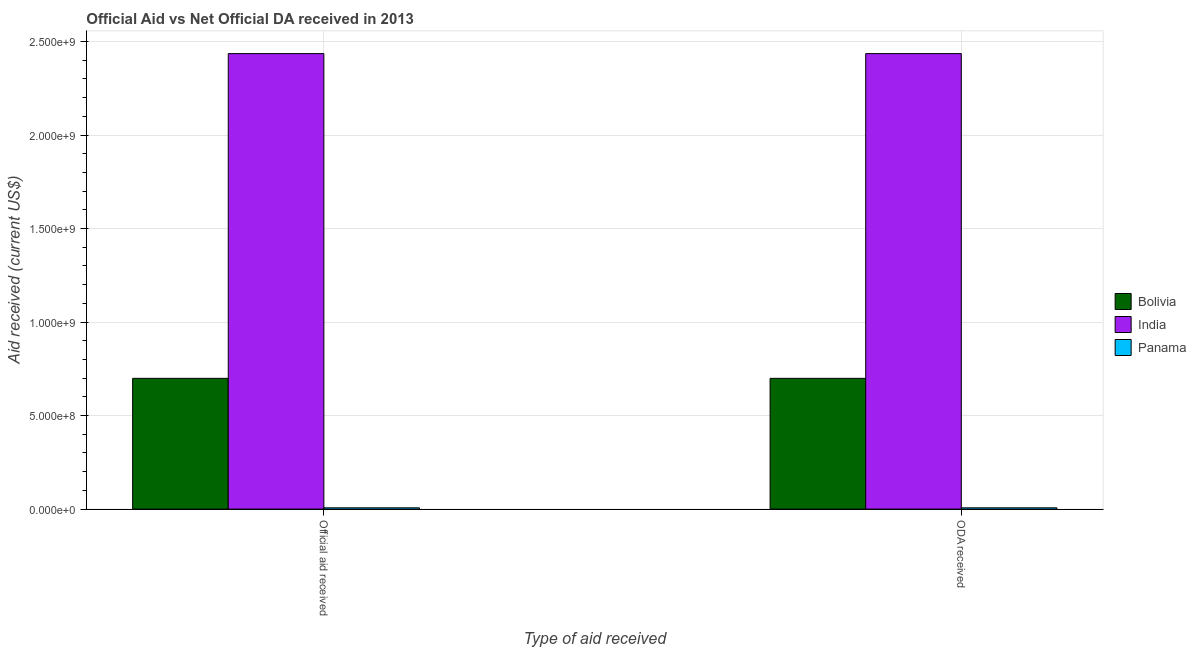How many groups of bars are there?
Give a very brief answer. 2. How many bars are there on the 2nd tick from the left?
Your response must be concise. 3. What is the label of the 1st group of bars from the left?
Your answer should be compact. Official aid received. What is the oda received in Bolivia?
Ensure brevity in your answer.  6.99e+08. Across all countries, what is the maximum official aid received?
Ensure brevity in your answer.  2.44e+09. Across all countries, what is the minimum official aid received?
Offer a very short reply. 6.87e+06. In which country was the official aid received minimum?
Ensure brevity in your answer.  Panama. What is the total oda received in the graph?
Provide a succinct answer. 3.14e+09. What is the difference between the official aid received in Bolivia and that in India?
Your answer should be very brief. -1.74e+09. What is the difference between the official aid received in Panama and the oda received in India?
Keep it short and to the point. -2.43e+09. What is the average oda received per country?
Offer a terse response. 1.05e+09. What is the difference between the official aid received and oda received in India?
Provide a succinct answer. 0. In how many countries, is the official aid received greater than 900000000 US$?
Your response must be concise. 1. What is the ratio of the official aid received in India to that in Bolivia?
Your answer should be very brief. 3.48. In how many countries, is the oda received greater than the average oda received taken over all countries?
Offer a very short reply. 1. What does the 3rd bar from the left in ODA received represents?
Offer a terse response. Panama. What does the 1st bar from the right in ODA received represents?
Keep it short and to the point. Panama. How many bars are there?
Your answer should be very brief. 6. How many countries are there in the graph?
Ensure brevity in your answer.  3. What is the difference between two consecutive major ticks on the Y-axis?
Keep it short and to the point. 5.00e+08. Are the values on the major ticks of Y-axis written in scientific E-notation?
Provide a succinct answer. Yes. Does the graph contain grids?
Offer a terse response. Yes. How many legend labels are there?
Keep it short and to the point. 3. What is the title of the graph?
Provide a succinct answer. Official Aid vs Net Official DA received in 2013 . Does "Italy" appear as one of the legend labels in the graph?
Make the answer very short. No. What is the label or title of the X-axis?
Ensure brevity in your answer.  Type of aid received. What is the label or title of the Y-axis?
Offer a very short reply. Aid received (current US$). What is the Aid received (current US$) in Bolivia in Official aid received?
Give a very brief answer. 6.99e+08. What is the Aid received (current US$) in India in Official aid received?
Your response must be concise. 2.44e+09. What is the Aid received (current US$) of Panama in Official aid received?
Keep it short and to the point. 6.87e+06. What is the Aid received (current US$) of Bolivia in ODA received?
Give a very brief answer. 6.99e+08. What is the Aid received (current US$) in India in ODA received?
Ensure brevity in your answer.  2.44e+09. What is the Aid received (current US$) in Panama in ODA received?
Ensure brevity in your answer.  6.87e+06. Across all Type of aid received, what is the maximum Aid received (current US$) in Bolivia?
Your response must be concise. 6.99e+08. Across all Type of aid received, what is the maximum Aid received (current US$) in India?
Keep it short and to the point. 2.44e+09. Across all Type of aid received, what is the maximum Aid received (current US$) in Panama?
Ensure brevity in your answer.  6.87e+06. Across all Type of aid received, what is the minimum Aid received (current US$) of Bolivia?
Give a very brief answer. 6.99e+08. Across all Type of aid received, what is the minimum Aid received (current US$) in India?
Offer a terse response. 2.44e+09. Across all Type of aid received, what is the minimum Aid received (current US$) of Panama?
Your answer should be very brief. 6.87e+06. What is the total Aid received (current US$) in Bolivia in the graph?
Provide a short and direct response. 1.40e+09. What is the total Aid received (current US$) of India in the graph?
Provide a succinct answer. 4.87e+09. What is the total Aid received (current US$) in Panama in the graph?
Your answer should be very brief. 1.37e+07. What is the difference between the Aid received (current US$) in India in Official aid received and that in ODA received?
Provide a succinct answer. 0. What is the difference between the Aid received (current US$) in Panama in Official aid received and that in ODA received?
Make the answer very short. 0. What is the difference between the Aid received (current US$) of Bolivia in Official aid received and the Aid received (current US$) of India in ODA received?
Ensure brevity in your answer.  -1.74e+09. What is the difference between the Aid received (current US$) in Bolivia in Official aid received and the Aid received (current US$) in Panama in ODA received?
Provide a short and direct response. 6.92e+08. What is the difference between the Aid received (current US$) in India in Official aid received and the Aid received (current US$) in Panama in ODA received?
Offer a very short reply. 2.43e+09. What is the average Aid received (current US$) of Bolivia per Type of aid received?
Offer a very short reply. 6.99e+08. What is the average Aid received (current US$) of India per Type of aid received?
Ensure brevity in your answer.  2.44e+09. What is the average Aid received (current US$) of Panama per Type of aid received?
Provide a succinct answer. 6.87e+06. What is the difference between the Aid received (current US$) of Bolivia and Aid received (current US$) of India in Official aid received?
Your response must be concise. -1.74e+09. What is the difference between the Aid received (current US$) of Bolivia and Aid received (current US$) of Panama in Official aid received?
Give a very brief answer. 6.92e+08. What is the difference between the Aid received (current US$) of India and Aid received (current US$) of Panama in Official aid received?
Your answer should be compact. 2.43e+09. What is the difference between the Aid received (current US$) in Bolivia and Aid received (current US$) in India in ODA received?
Give a very brief answer. -1.74e+09. What is the difference between the Aid received (current US$) of Bolivia and Aid received (current US$) of Panama in ODA received?
Provide a short and direct response. 6.92e+08. What is the difference between the Aid received (current US$) of India and Aid received (current US$) of Panama in ODA received?
Keep it short and to the point. 2.43e+09. What is the ratio of the Aid received (current US$) of India in Official aid received to that in ODA received?
Your answer should be very brief. 1. What is the ratio of the Aid received (current US$) of Panama in Official aid received to that in ODA received?
Offer a very short reply. 1. What is the difference between the highest and the second highest Aid received (current US$) of Bolivia?
Your answer should be compact. 0. What is the difference between the highest and the second highest Aid received (current US$) of India?
Make the answer very short. 0. What is the difference between the highest and the second highest Aid received (current US$) of Panama?
Your response must be concise. 0. What is the difference between the highest and the lowest Aid received (current US$) in Bolivia?
Provide a short and direct response. 0. 